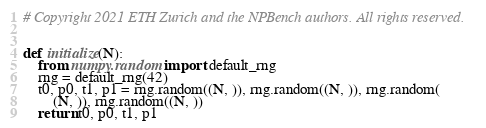<code> <loc_0><loc_0><loc_500><loc_500><_Python_># Copyright 2021 ETH Zurich and the NPBench authors. All rights reserved.


def initialize(N):
    from numpy.random import default_rng
    rng = default_rng(42)
    t0, p0, t1, p1 = rng.random((N, )), rng.random((N, )), rng.random(
        (N, )), rng.random((N, ))
    return t0, p0, t1, p1
</code> 